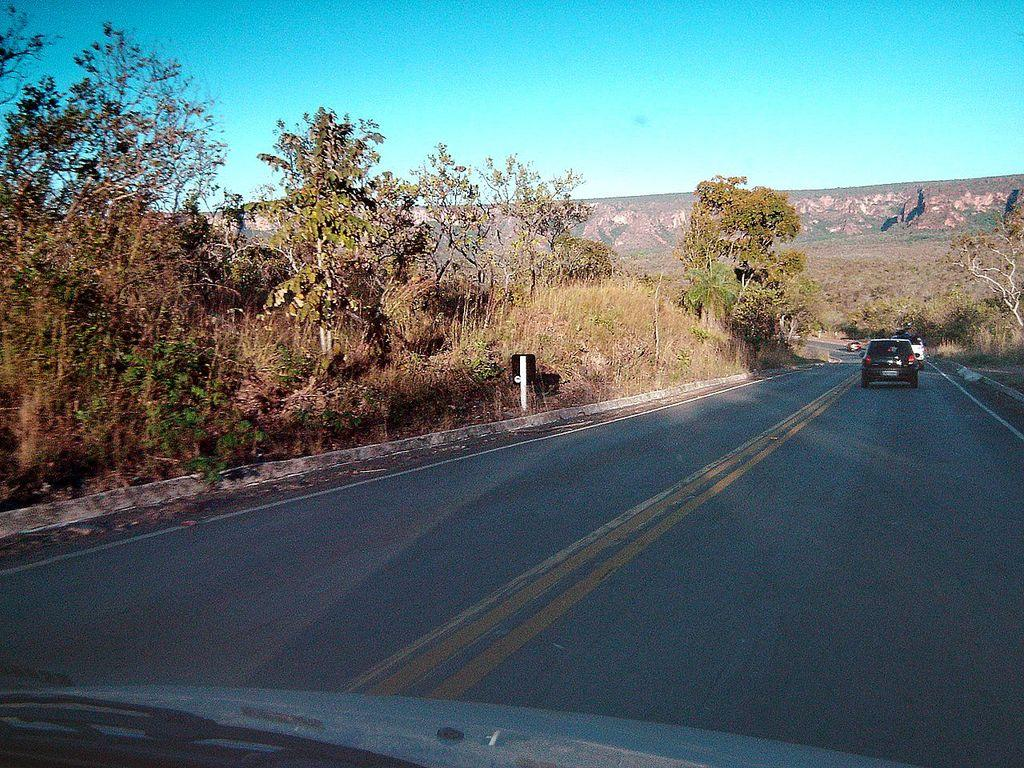What is happening on the road in the image? There are cars on a road in the image. What can be seen on both sides of the road? There are trees on either side of the road. What is visible in the distance behind the road? There is a mountain in the background of the image. What else can be seen in the background of the image? The sky is visible in the background of the image. Can you tell me how many buttons are on the leg of the car in the image? There are no buttons or legs on the cars in the image; they are vehicles with wheels, not animals with legs. 